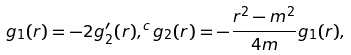Convert formula to latex. <formula><loc_0><loc_0><loc_500><loc_500>g _ { 1 } ( r ) = - 2 g _ { 2 } ^ { \prime } ( r ) , ^ { c } g _ { 2 } ( r ) = - \frac { r ^ { 2 } - m ^ { 2 } } { 4 m } g _ { 1 } ( r ) ,</formula> 